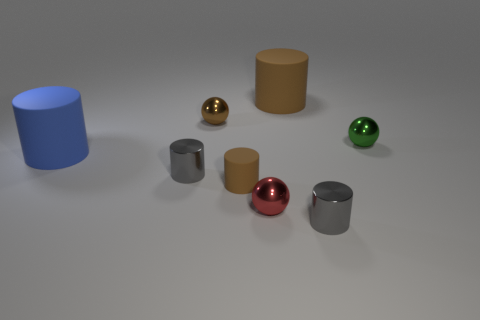Subtract 1 balls. How many balls are left? 2 Subtract all blue cylinders. How many cylinders are left? 4 Subtract all tiny rubber cylinders. How many cylinders are left? 4 Add 2 metallic spheres. How many objects exist? 10 Subtract all purple cylinders. Subtract all yellow cubes. How many cylinders are left? 5 Subtract all balls. How many objects are left? 5 Add 3 large cylinders. How many large cylinders exist? 5 Subtract 0 purple blocks. How many objects are left? 8 Subtract all small cylinders. Subtract all large matte things. How many objects are left? 3 Add 1 big brown objects. How many big brown objects are left? 2 